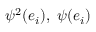<formula> <loc_0><loc_0><loc_500><loc_500>\psi ^ { 2 } ( e _ { i } ) , \, \psi ( e _ { i } )</formula> 